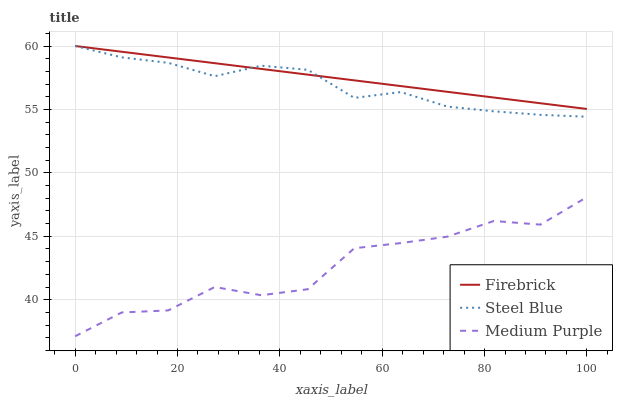Does Steel Blue have the minimum area under the curve?
Answer yes or no. No. Does Steel Blue have the maximum area under the curve?
Answer yes or no. No. Is Steel Blue the smoothest?
Answer yes or no. No. Is Steel Blue the roughest?
Answer yes or no. No. Does Steel Blue have the lowest value?
Answer yes or no. No. Is Medium Purple less than Steel Blue?
Answer yes or no. Yes. Is Steel Blue greater than Medium Purple?
Answer yes or no. Yes. Does Medium Purple intersect Steel Blue?
Answer yes or no. No. 